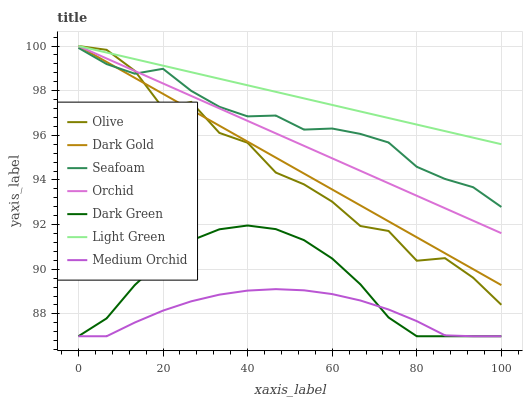Does Medium Orchid have the minimum area under the curve?
Answer yes or no. Yes. Does Light Green have the maximum area under the curve?
Answer yes or no. Yes. Does Seafoam have the minimum area under the curve?
Answer yes or no. No. Does Seafoam have the maximum area under the curve?
Answer yes or no. No. Is Orchid the smoothest?
Answer yes or no. Yes. Is Olive the roughest?
Answer yes or no. Yes. Is Medium Orchid the smoothest?
Answer yes or no. No. Is Medium Orchid the roughest?
Answer yes or no. No. Does Seafoam have the lowest value?
Answer yes or no. No. Does Orchid have the highest value?
Answer yes or no. Yes. Does Seafoam have the highest value?
Answer yes or no. No. Is Dark Green less than Light Green?
Answer yes or no. Yes. Is Olive greater than Medium Orchid?
Answer yes or no. Yes. Does Orchid intersect Light Green?
Answer yes or no. Yes. Is Orchid less than Light Green?
Answer yes or no. No. Is Orchid greater than Light Green?
Answer yes or no. No. Does Dark Green intersect Light Green?
Answer yes or no. No. 